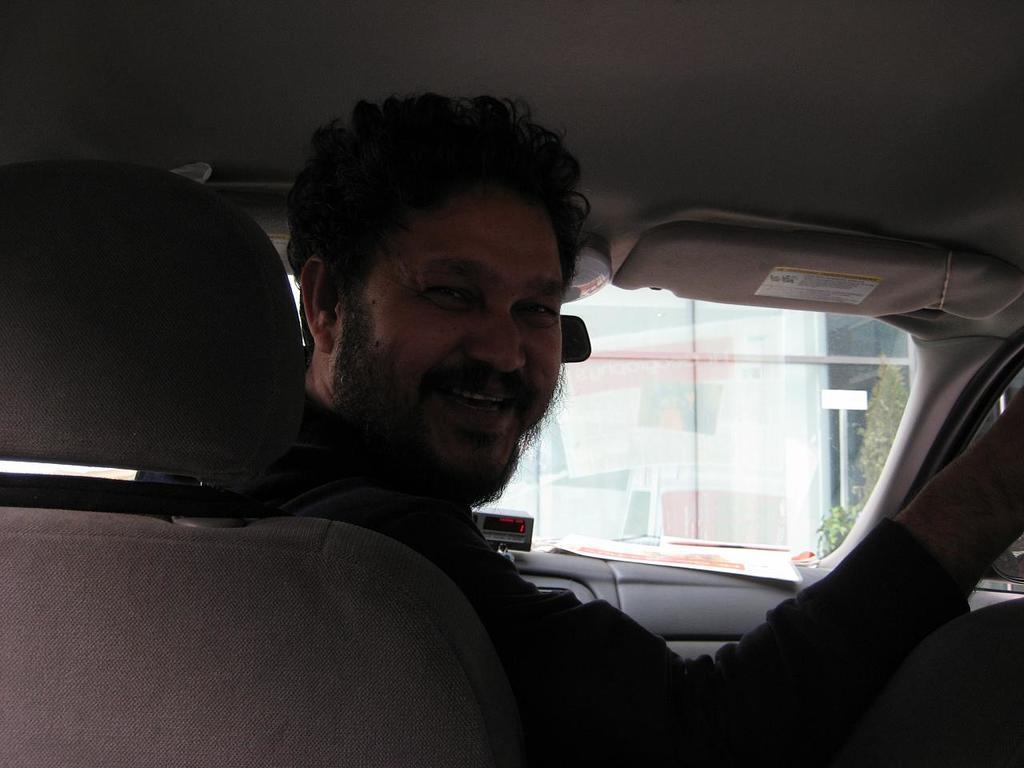Please provide a concise description of this image. In the image we see there is a man infront who is smiling and he is wearing a black jacket and he is sitting in a car. 